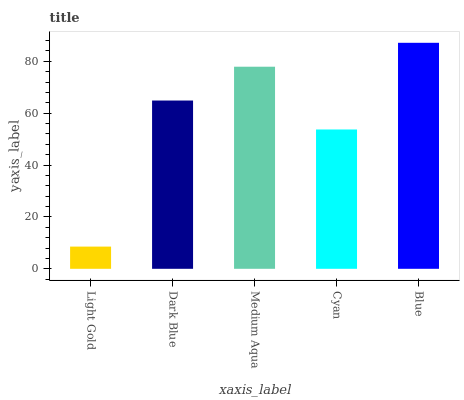Is Dark Blue the minimum?
Answer yes or no. No. Is Dark Blue the maximum?
Answer yes or no. No. Is Dark Blue greater than Light Gold?
Answer yes or no. Yes. Is Light Gold less than Dark Blue?
Answer yes or no. Yes. Is Light Gold greater than Dark Blue?
Answer yes or no. No. Is Dark Blue less than Light Gold?
Answer yes or no. No. Is Dark Blue the high median?
Answer yes or no. Yes. Is Dark Blue the low median?
Answer yes or no. Yes. Is Blue the high median?
Answer yes or no. No. Is Light Gold the low median?
Answer yes or no. No. 